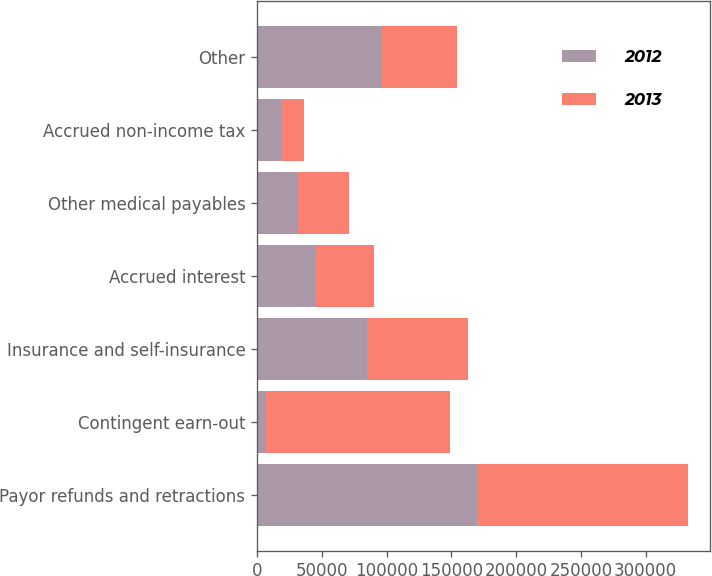<chart> <loc_0><loc_0><loc_500><loc_500><stacked_bar_chart><ecel><fcel>Payor refunds and retractions<fcel>Contingent earn-out<fcel>Insurance and self-insurance<fcel>Accrued interest<fcel>Other medical payables<fcel>Accrued non-income tax<fcel>Other<nl><fcel>2012<fcel>169480<fcel>6577<fcel>84882<fcel>45662<fcel>31219<fcel>18366<fcel>96167<nl><fcel>2013<fcel>163520<fcel>142244<fcel>78073<fcel>44884<fcel>39698<fcel>17976<fcel>58530<nl></chart> 